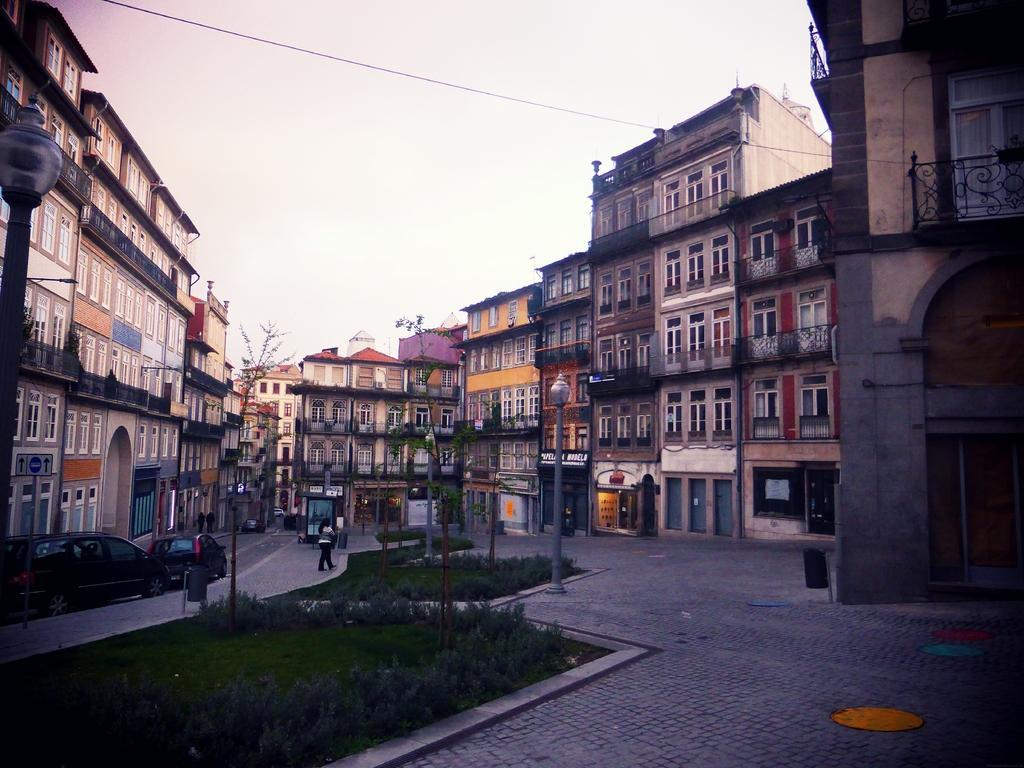Can you describe this image briefly? In the picture picture we can see the grass surface, poles with lamps, road and some people are standing on it and buildings and behind it we can see the sky. 